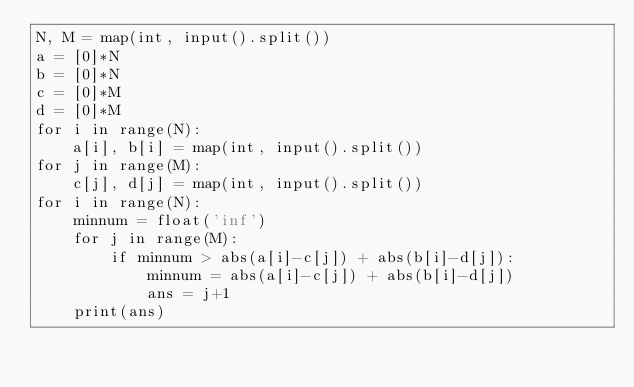<code> <loc_0><loc_0><loc_500><loc_500><_Python_>N, M = map(int, input().split())
a = [0]*N
b = [0]*N
c = [0]*M
d = [0]*M
for i in range(N):
    a[i], b[i] = map(int, input().split())
for j in range(M):
    c[j], d[j] = map(int, input().split())
for i in range(N):
    minnum = float('inf')
    for j in range(M):
        if minnum > abs(a[i]-c[j]) + abs(b[i]-d[j]):
            minnum = abs(a[i]-c[j]) + abs(b[i]-d[j])
            ans = j+1
    print(ans)</code> 